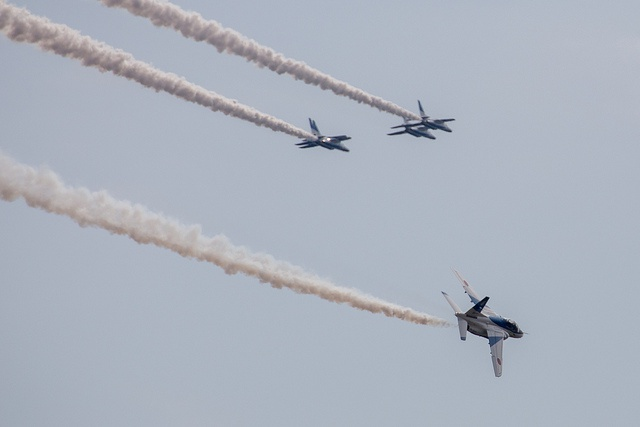Describe the objects in this image and their specific colors. I can see airplane in darkgray, gray, and black tones, airplane in darkgray, gray, and navy tones, airplane in darkgray, gray, and navy tones, and airplane in darkgray, navy, gray, and darkblue tones in this image. 